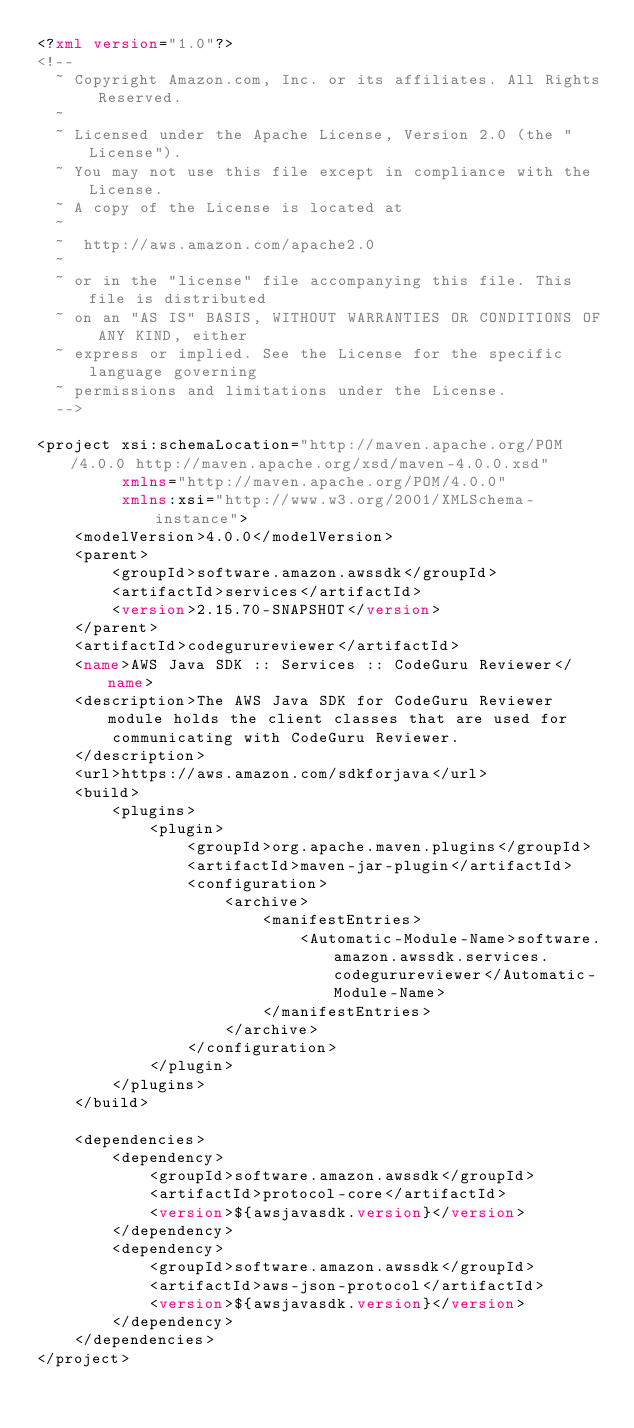<code> <loc_0><loc_0><loc_500><loc_500><_XML_><?xml version="1.0"?>
<!--
  ~ Copyright Amazon.com, Inc. or its affiliates. All Rights Reserved.
  ~
  ~ Licensed under the Apache License, Version 2.0 (the "License").
  ~ You may not use this file except in compliance with the License.
  ~ A copy of the License is located at
  ~
  ~  http://aws.amazon.com/apache2.0
  ~
  ~ or in the "license" file accompanying this file. This file is distributed
  ~ on an "AS IS" BASIS, WITHOUT WARRANTIES OR CONDITIONS OF ANY KIND, either
  ~ express or implied. See the License for the specific language governing
  ~ permissions and limitations under the License.
  -->

<project xsi:schemaLocation="http://maven.apache.org/POM/4.0.0 http://maven.apache.org/xsd/maven-4.0.0.xsd"
         xmlns="http://maven.apache.org/POM/4.0.0"
         xmlns:xsi="http://www.w3.org/2001/XMLSchema-instance">
    <modelVersion>4.0.0</modelVersion>
    <parent>
        <groupId>software.amazon.awssdk</groupId>
        <artifactId>services</artifactId>
        <version>2.15.70-SNAPSHOT</version>
    </parent>
    <artifactId>codegurureviewer</artifactId>
    <name>AWS Java SDK :: Services :: CodeGuru Reviewer</name>
    <description>The AWS Java SDK for CodeGuru Reviewer module holds the client classes that are used for
        communicating with CodeGuru Reviewer.
    </description>
    <url>https://aws.amazon.com/sdkforjava</url>
    <build>
        <plugins>
            <plugin>
                <groupId>org.apache.maven.plugins</groupId>
                <artifactId>maven-jar-plugin</artifactId>
                <configuration>
                    <archive>
                        <manifestEntries>
                            <Automatic-Module-Name>software.amazon.awssdk.services.codegurureviewer</Automatic-Module-Name>
                        </manifestEntries>
                    </archive>
                </configuration>
            </plugin>
        </plugins>
    </build>

    <dependencies>
        <dependency>
            <groupId>software.amazon.awssdk</groupId>
            <artifactId>protocol-core</artifactId>
            <version>${awsjavasdk.version}</version>
        </dependency>
        <dependency>
            <groupId>software.amazon.awssdk</groupId>
            <artifactId>aws-json-protocol</artifactId>
            <version>${awsjavasdk.version}</version>
        </dependency>
    </dependencies>
</project>
</code> 